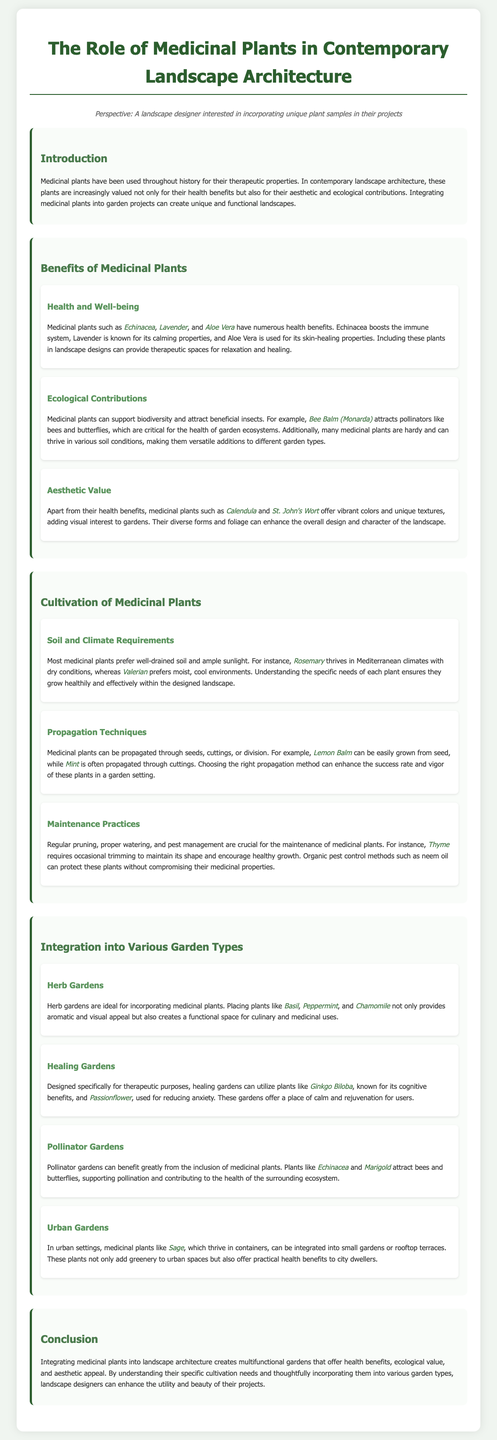what are some health benefits of Echinacea? Echinacea boosts the immune system.
Answer: boosts the immune system which medicinal plant is known for its calming properties? Lavender is known for its calming properties.
Answer: Lavender what type of soil do most medicinal plants prefer? Most medicinal plants prefer well-drained soil.
Answer: well-drained soil which gardening type supports pollination and includes Echinacea? Pollinator gardens can benefit greatly from the inclusion of medicinal plants like Echinacea.
Answer: Pollinator gardens how can medicinal plants contribute to biodiversity? Medicinal plants can support biodiversity and attract beneficial insects.
Answer: support biodiversity what is a recommended propagation technique for Mint? Mint is often propagated through cuttings.
Answer: cuttings which medicinal plant thrives in Mediterranean climates? Rosemary thrives in Mediterranean climates.
Answer: Rosemary what is a feature of healing gardens? Healing gardens are designed specifically for therapeutic purposes.
Answer: therapeutic purposes 